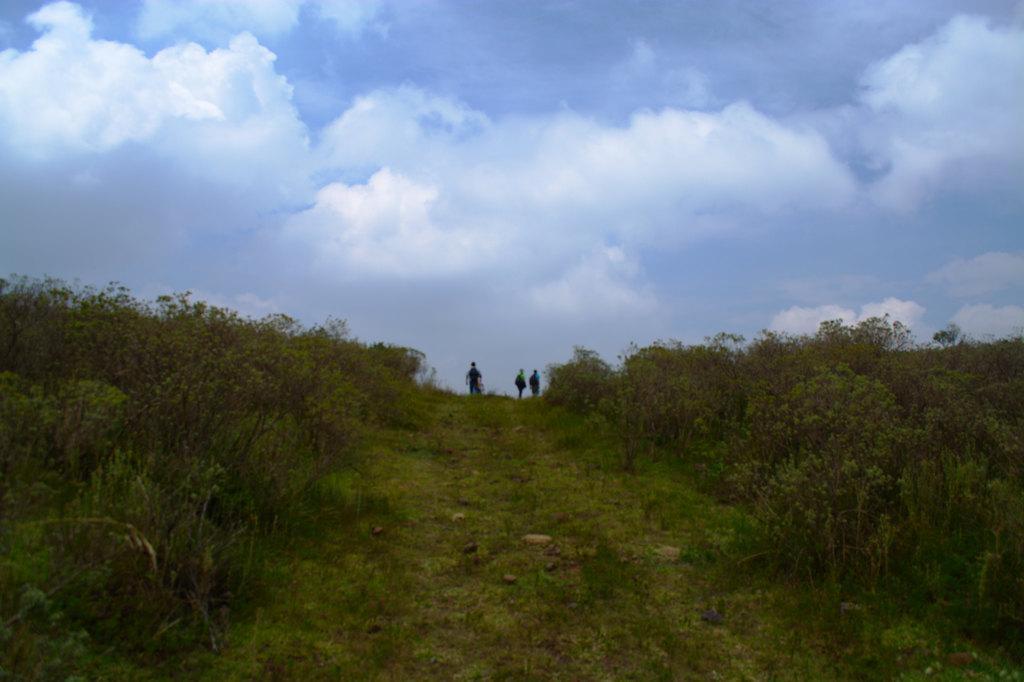How would you summarize this image in a sentence or two? In the picture there is a slope and it is filled with a lot of grass and plants, above the slope there are three people and in the background there is a sky. 